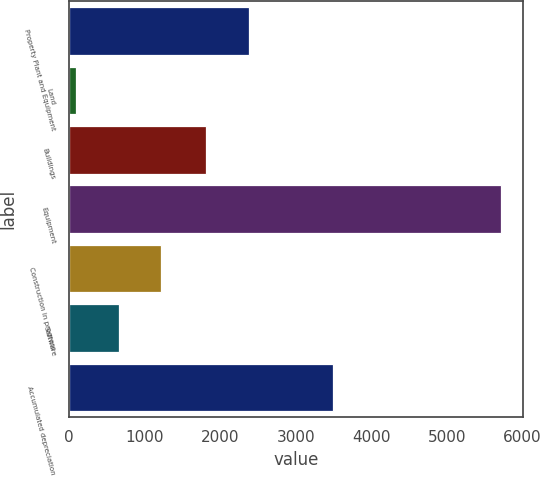Convert chart. <chart><loc_0><loc_0><loc_500><loc_500><bar_chart><fcel>Property Plant and Equipment<fcel>Land<fcel>Buildings<fcel>Equipment<fcel>Construction in progress<fcel>Software<fcel>Accumulated depreciation<nl><fcel>2377.76<fcel>94.7<fcel>1815.1<fcel>5721.3<fcel>1220.02<fcel>657.36<fcel>3494.8<nl></chart> 